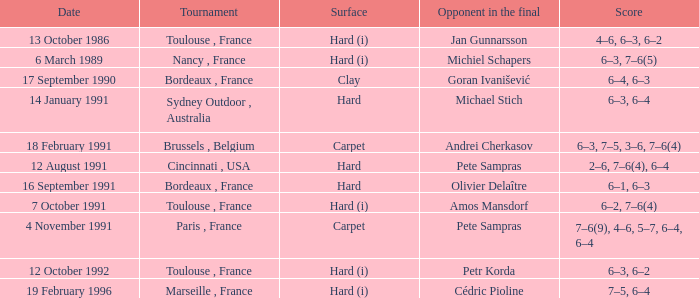What is the date of the tournament with olivier delaître as the opponent in the final? 16 September 1991. 